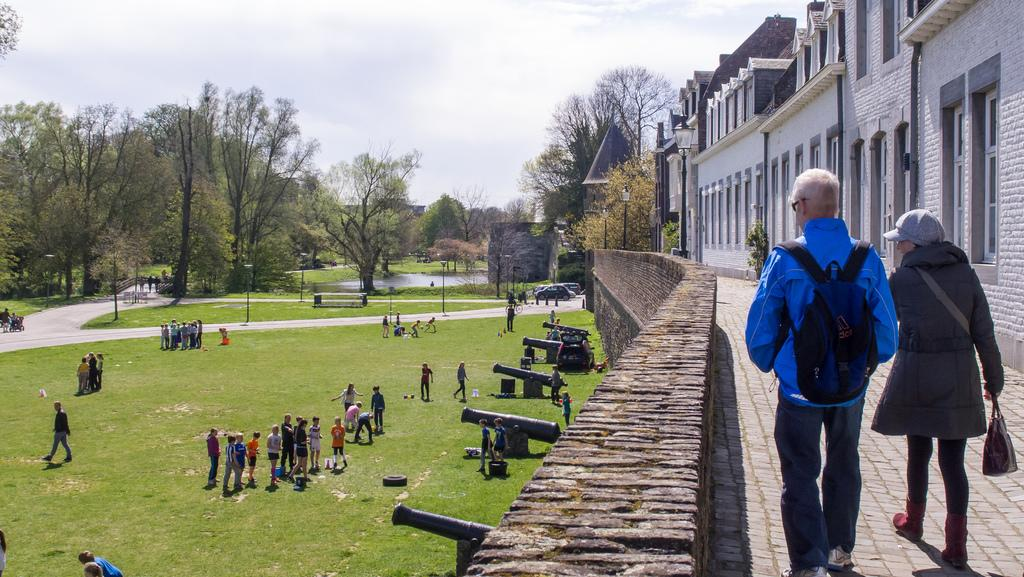How many people are present in the image? There are two persons in the image. What can be seen in the right corner of the image? There are buildings in the right corner of the image. What is located beside the persons and buildings? There is a wall beside the persons and buildings. Where are the people standing in the image? The people are standing on a greenery ground. What is visible in the background of the image? There are trees in the background of the image. What type of disease is affecting the geese in the image? There are no geese present in the image, so it is not possible to determine if any disease is affecting them. 